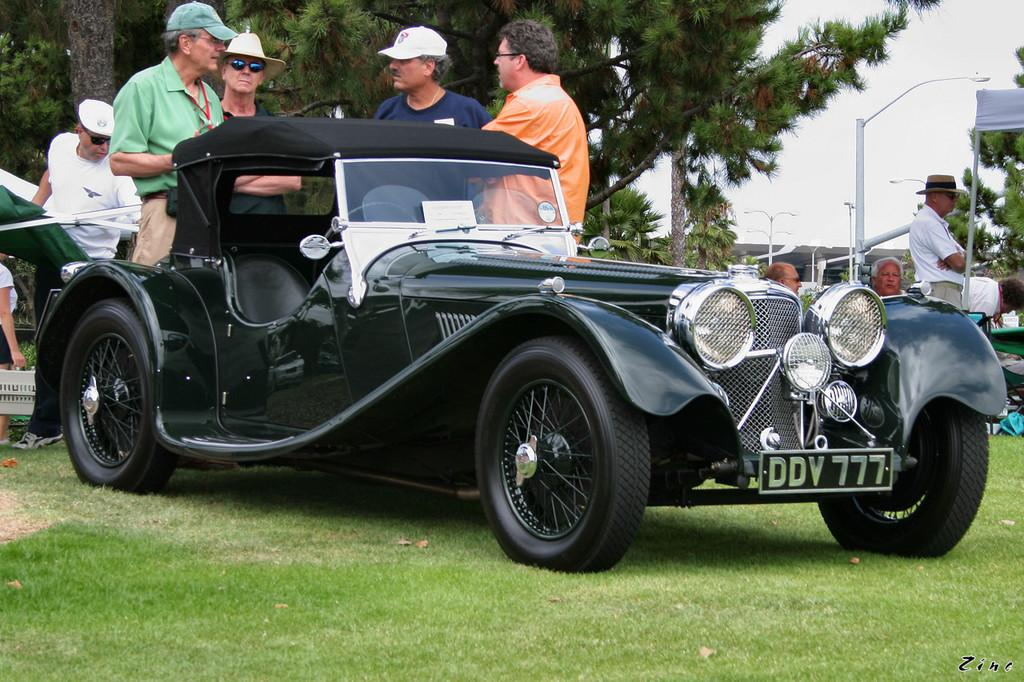What is located on the ground in the image? There is a car on the ground in the image. What can be seen in the background of the image? There are people standing, people sitting, trees, and poles in the background of the image. What type of produce is being harvested by the people in the image? There is no produce or harvesting activity depicted in the image. What type of quill is being used by the people in the image? There is no quill present in the image. 